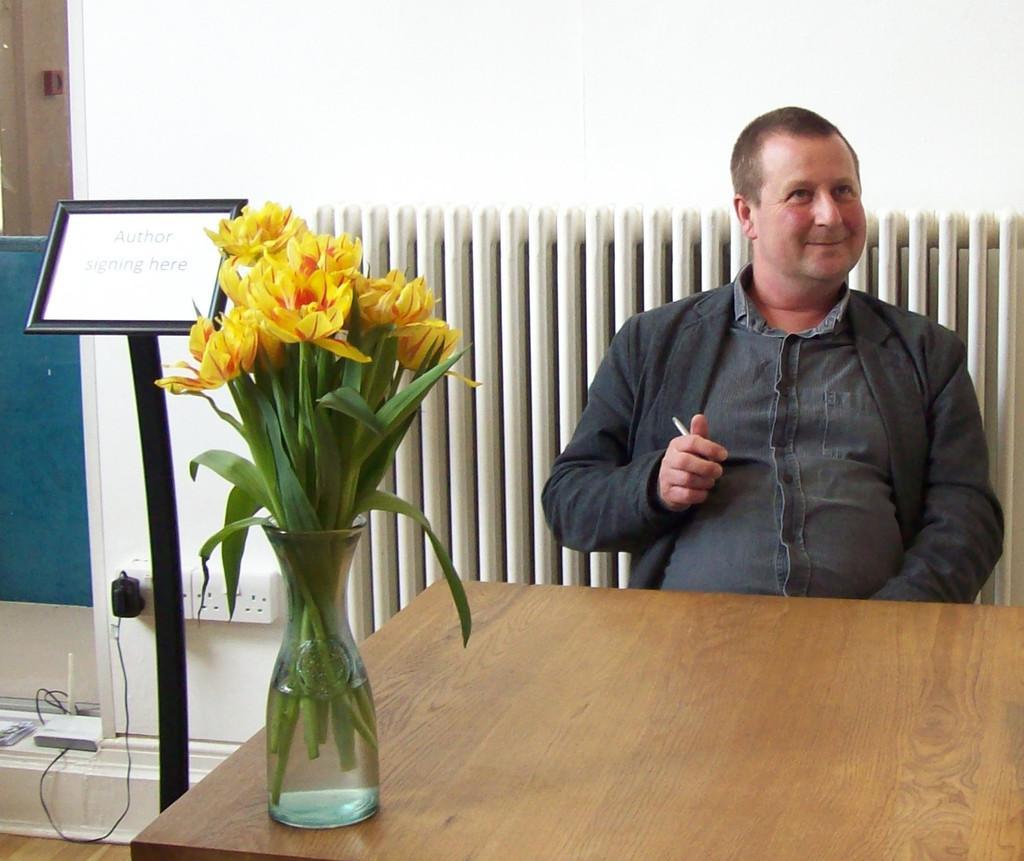Describe this image in one or two sentences. In this image I can see a man. On the table there is a flower pot. There is a board. At the back side there is a wall. 